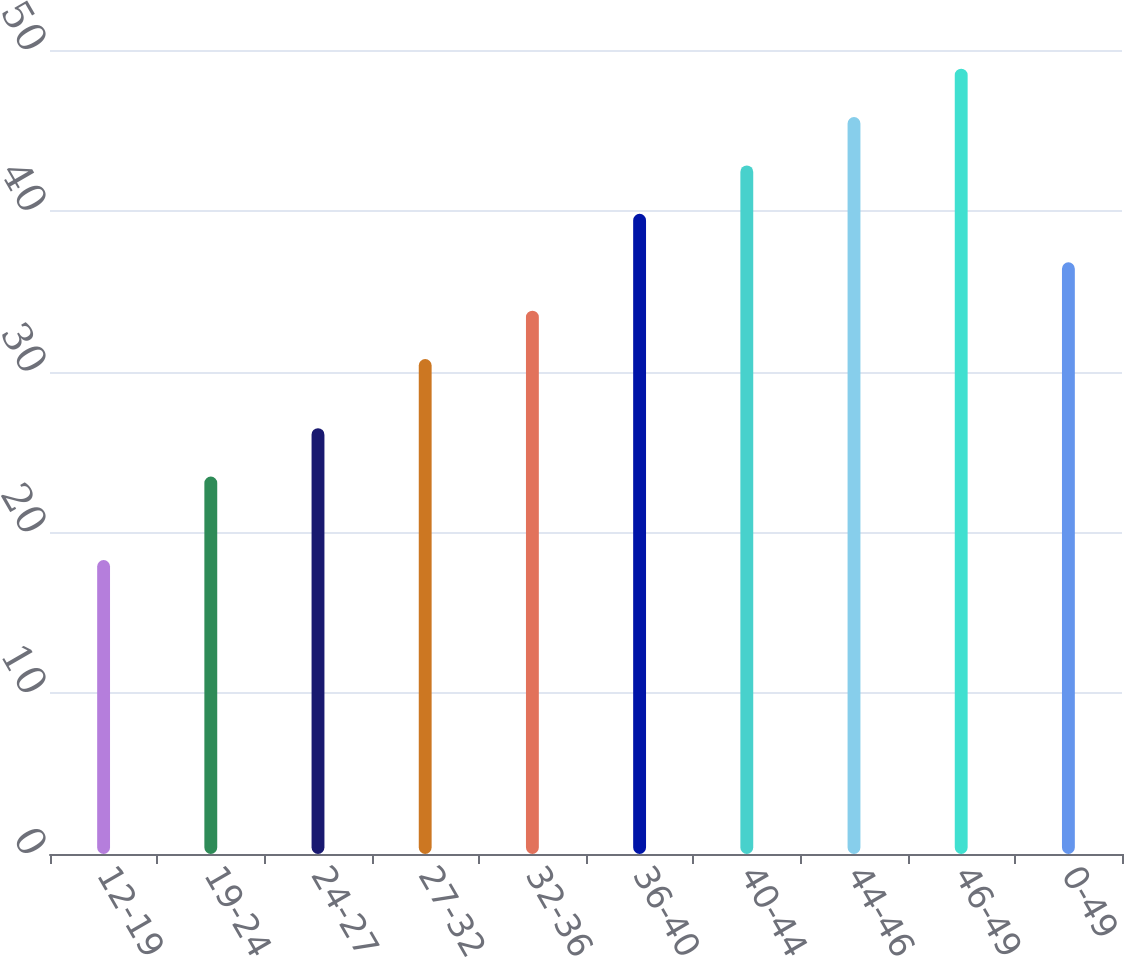Convert chart. <chart><loc_0><loc_0><loc_500><loc_500><bar_chart><fcel>12-19<fcel>19-24<fcel>24-27<fcel>27-32<fcel>32-36<fcel>36-40<fcel>40-44<fcel>44-46<fcel>46-49<fcel>0-49<nl><fcel>18.28<fcel>23.47<fcel>26.48<fcel>30.78<fcel>33.79<fcel>39.81<fcel>42.82<fcel>45.83<fcel>48.84<fcel>36.8<nl></chart> 